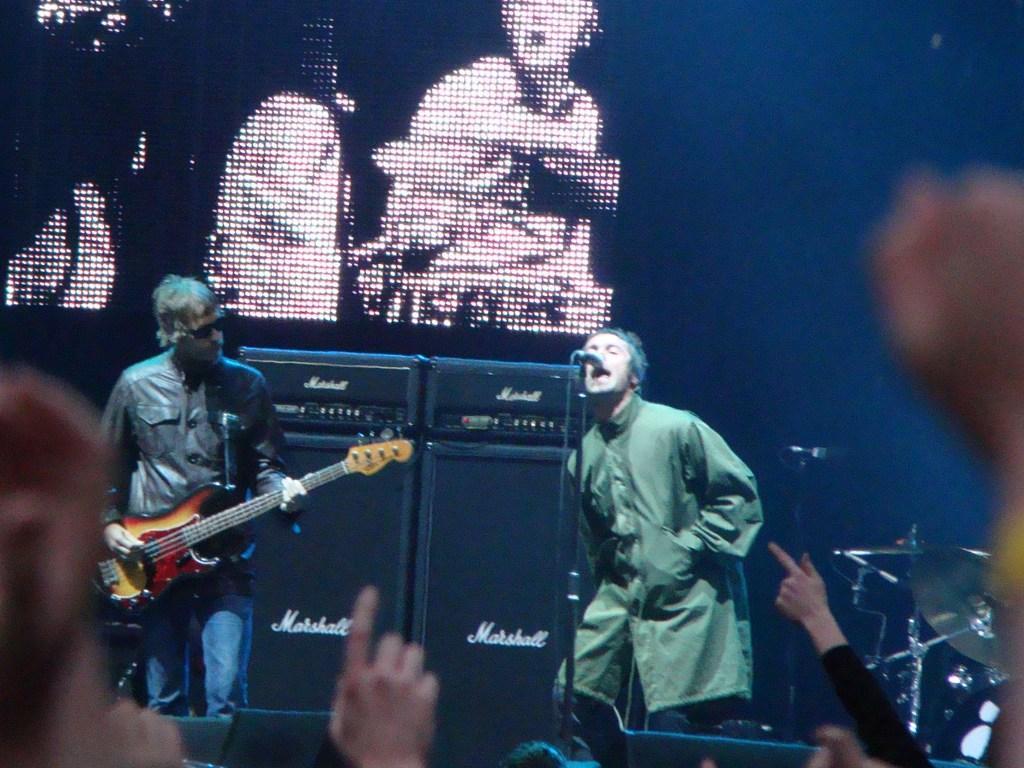Describe this image in one or two sentences. In this image on the right side there is one person who is standing in front of him there is one mike it seems that he is singing. On the left side there is one person who is standing and he is holding a guitar on the background there is a screen on the right side and left side there are some people. 